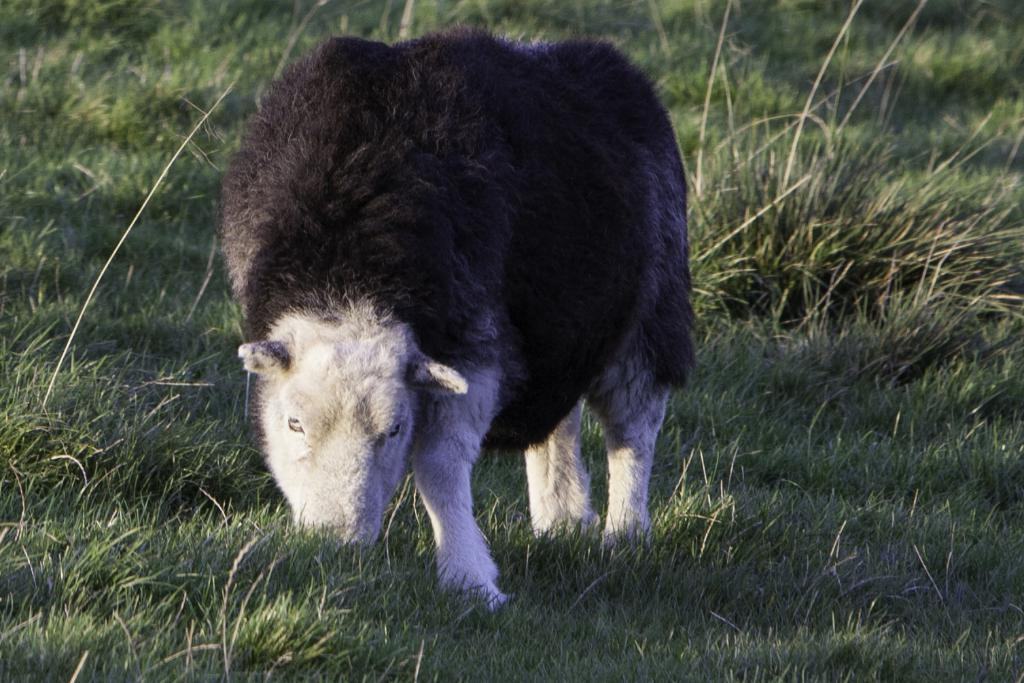What type of animal is present in the image? There is an animal in the image. What is the animal doing in the image? The animal is eating grass. What type of education is the animal receiving in the image? There is no indication in the image that the animal is receiving any education. What type of destruction is the animal causing in the image? There is no destruction present in the image; the animal is simply eating grass. Are there any dinosaurs visible in the image? There is no mention of dinosaurs in the provided facts, and therefore no dinosaurs are present in the image. 